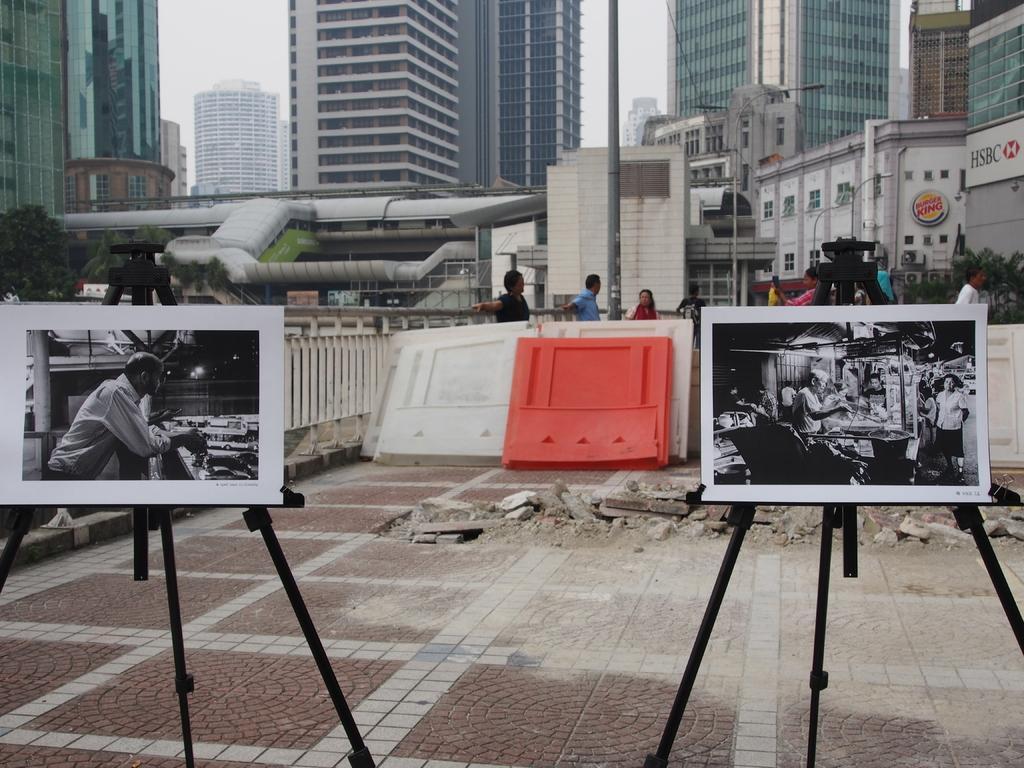How would you summarize this image in a sentence or two? In front of the picture, we see two stands on which photos containing papers are placed. At the bottom, we see the pavement. Behind that, we see boards in white and orange color. Beside that, we see a railing. We see people are standing on the road. There are trees, buildings and a pole in the background. This picture is clicked outside the city. 